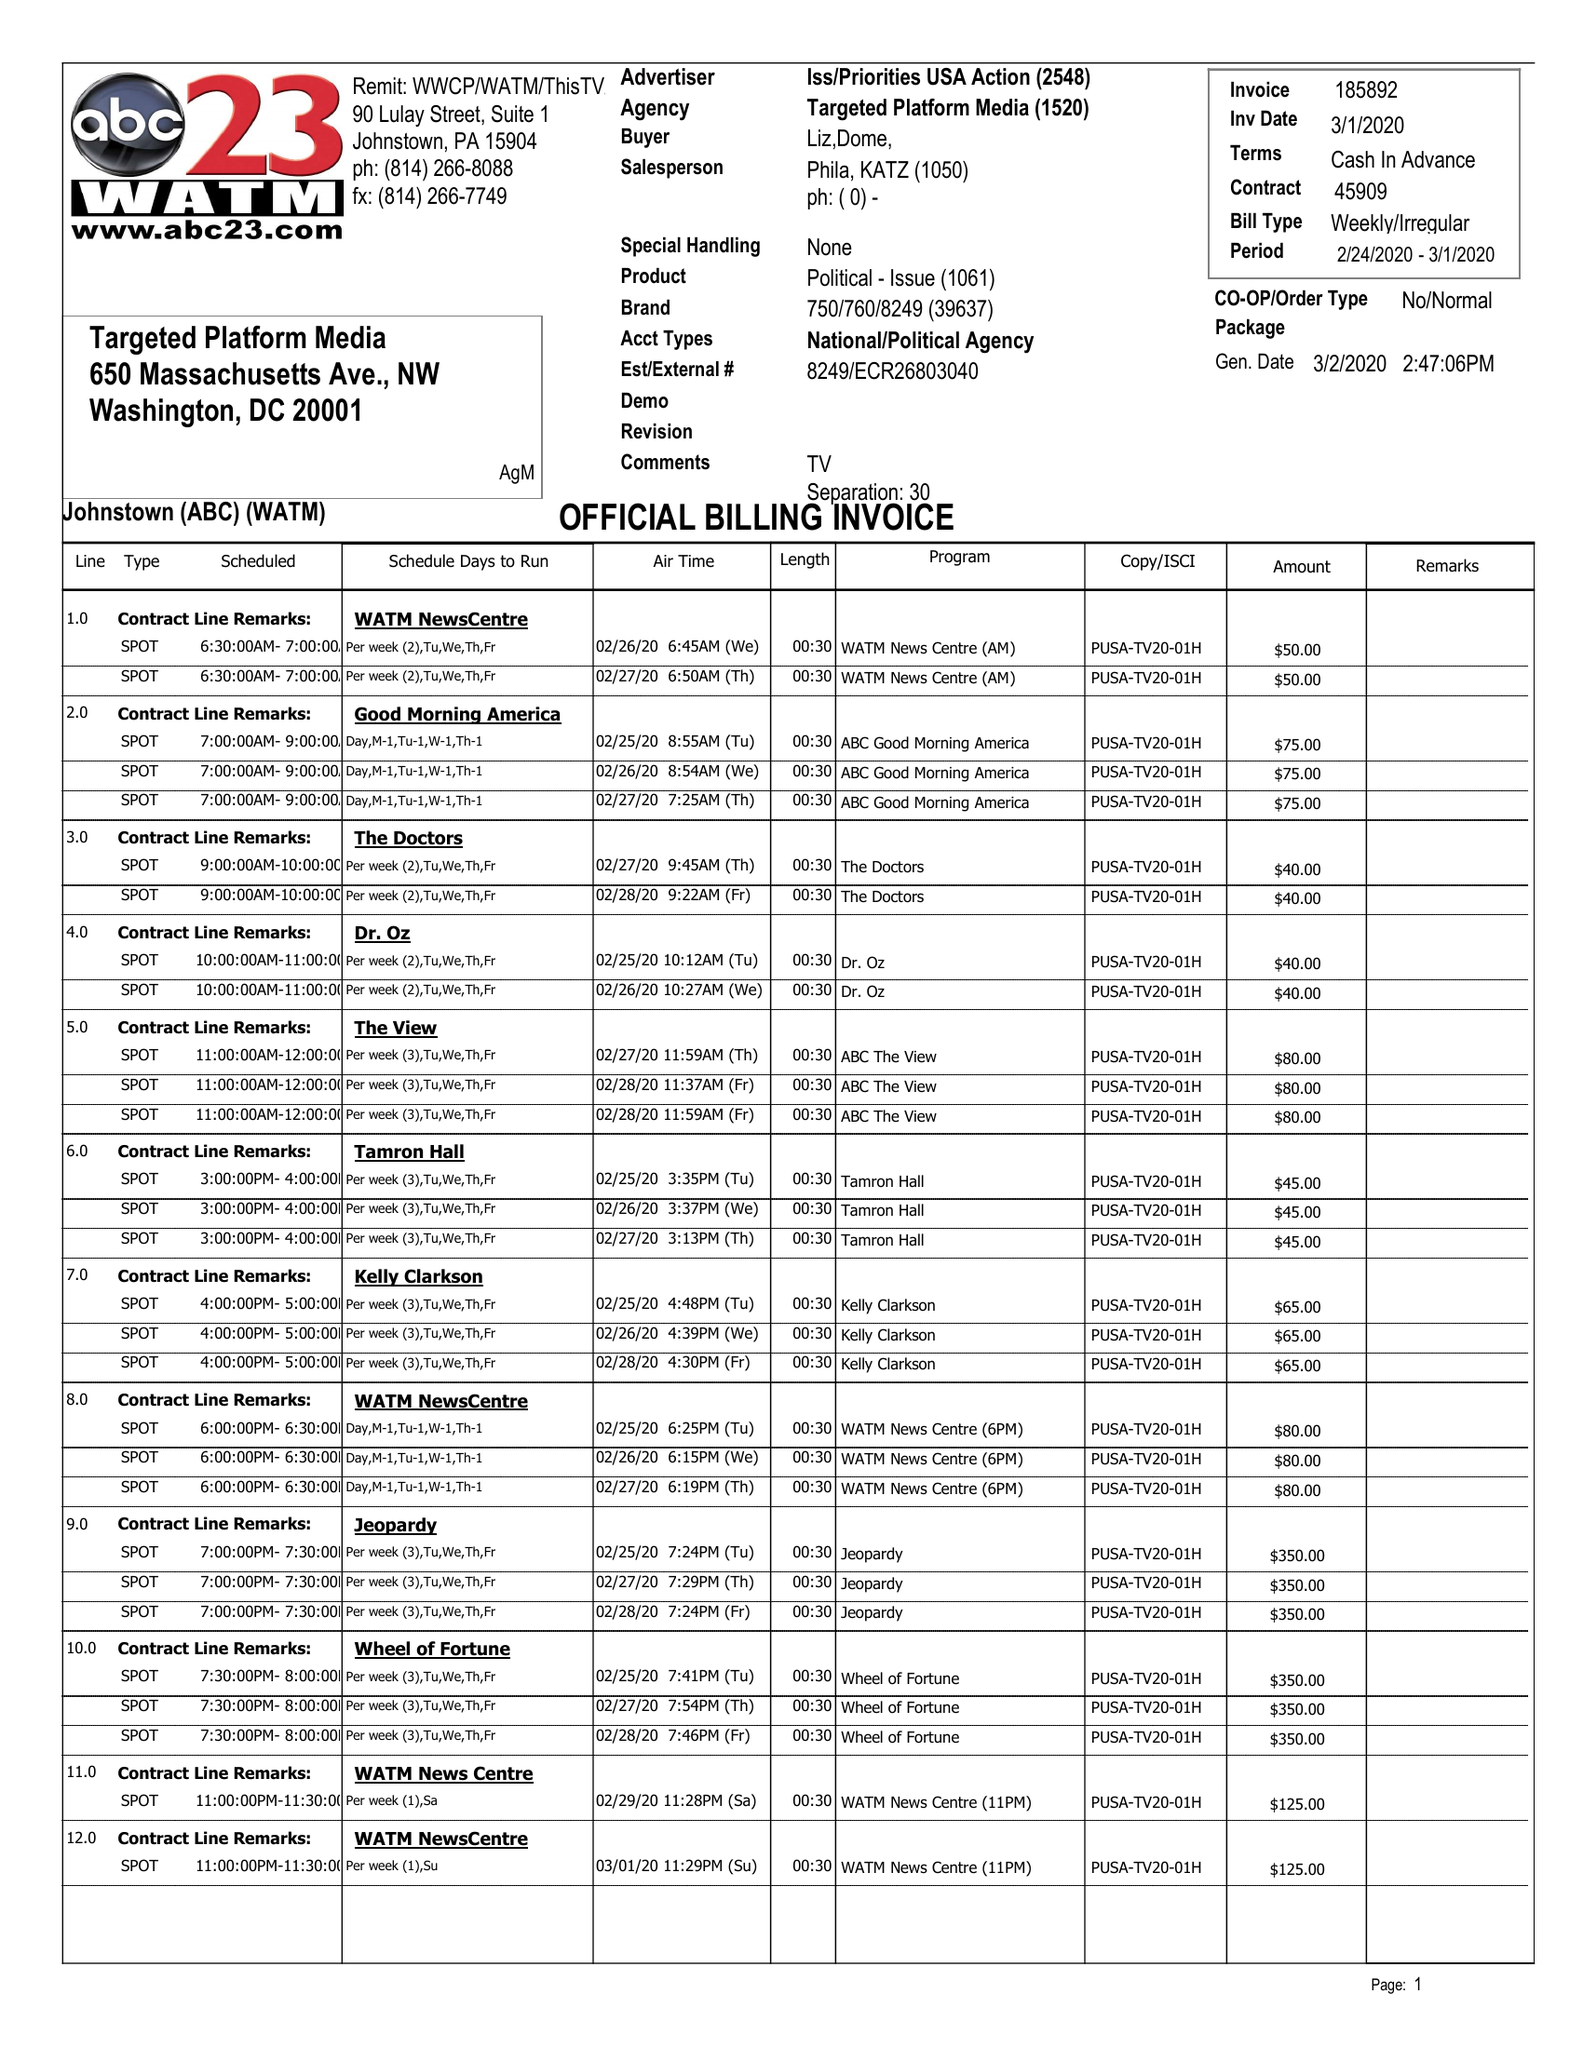What is the value for the contract_num?
Answer the question using a single word or phrase. 45908 